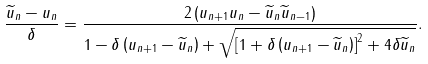Convert formula to latex. <formula><loc_0><loc_0><loc_500><loc_500>\frac { \widetilde { u } _ { n } - u _ { n } } { \delta } = \frac { 2 \left ( u _ { n + 1 } u _ { n } - \widetilde { u } _ { n } \widetilde { u } _ { n - 1 } \right ) } { 1 - \delta \left ( u _ { n + 1 } - \widetilde { u } _ { n } \right ) + \sqrt { \left [ 1 + \delta \left ( u _ { n + 1 } - \widetilde { u } _ { n } \right ) \right ] ^ { 2 } + 4 \delta \widetilde { u } _ { n } } } .</formula> 